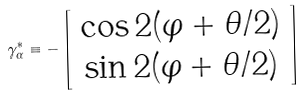Convert formula to latex. <formula><loc_0><loc_0><loc_500><loc_500>\gamma _ { \alpha } ^ { * } \equiv - \left [ \begin{array} { c } \cos 2 ( \varphi + \theta / 2 ) \\ \sin 2 ( \varphi + \theta / 2 ) \end{array} \right ]</formula> 